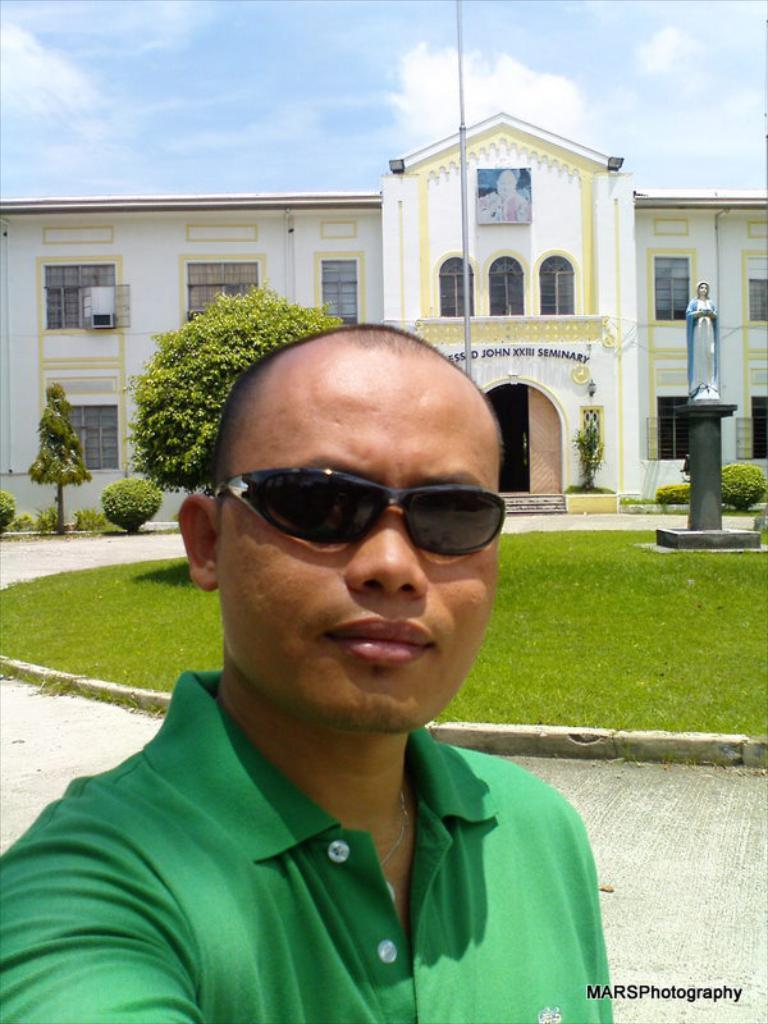What is the main subject of the image? There is a person in the image. Can you describe the person's clothing? The person is wearing a green dress. Where is the person standing in relation to the building? The person is standing in front of a building. What features can be observed on the building? The building has doors. What type of vehicles are near the building? There are buses near the building. What is located on the grass floor in the image? There is a statue on the grass floor. What type of throat can be seen on the statue in the image? There is no throat visible on the statue in the image, as statues do not have internal organs like throats. 